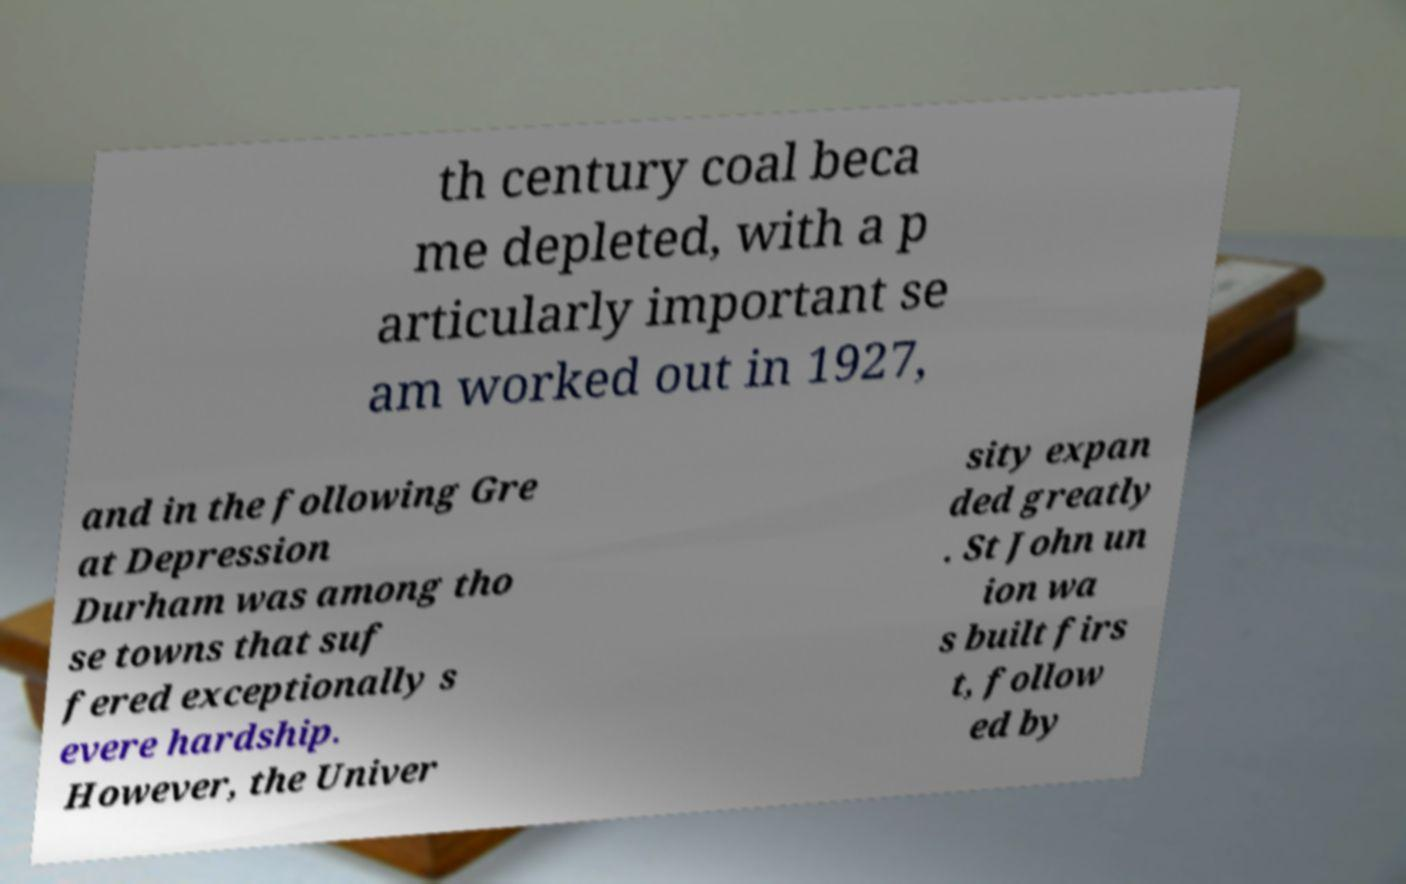Can you accurately transcribe the text from the provided image for me? th century coal beca me depleted, with a p articularly important se am worked out in 1927, and in the following Gre at Depression Durham was among tho se towns that suf fered exceptionally s evere hardship. However, the Univer sity expan ded greatly . St John un ion wa s built firs t, follow ed by 